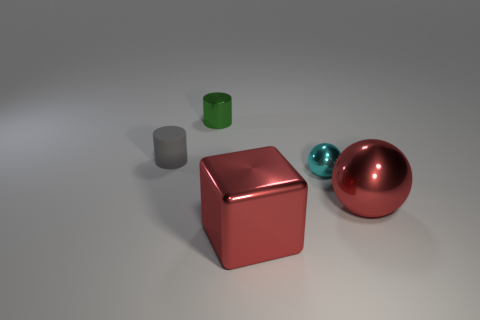Is the material of the small cyan ball in front of the matte cylinder the same as the tiny green object?
Your answer should be very brief. Yes. What is the color of the sphere that is the same size as the green thing?
Keep it short and to the point. Cyan. Is there another tiny thing of the same shape as the small gray rubber thing?
Your answer should be compact. Yes. What color is the sphere left of the shiny sphere in front of the tiny cyan metal thing that is in front of the tiny gray object?
Your answer should be compact. Cyan. How many rubber things are tiny purple cylinders or small cyan spheres?
Offer a very short reply. 0. Are there more red metal things that are left of the large red shiny ball than tiny cyan metal balls that are behind the cyan shiny thing?
Offer a very short reply. Yes. What number of other objects are there of the same size as the cyan object?
Provide a succinct answer. 2. What size is the gray cylinder behind the small thing in front of the gray object?
Make the answer very short. Small. What number of tiny objects are red matte balls or gray rubber objects?
Offer a terse response. 1. There is a red metallic thing that is to the right of the large red object that is to the left of the big red shiny thing that is on the right side of the big shiny block; how big is it?
Provide a succinct answer. Large. 